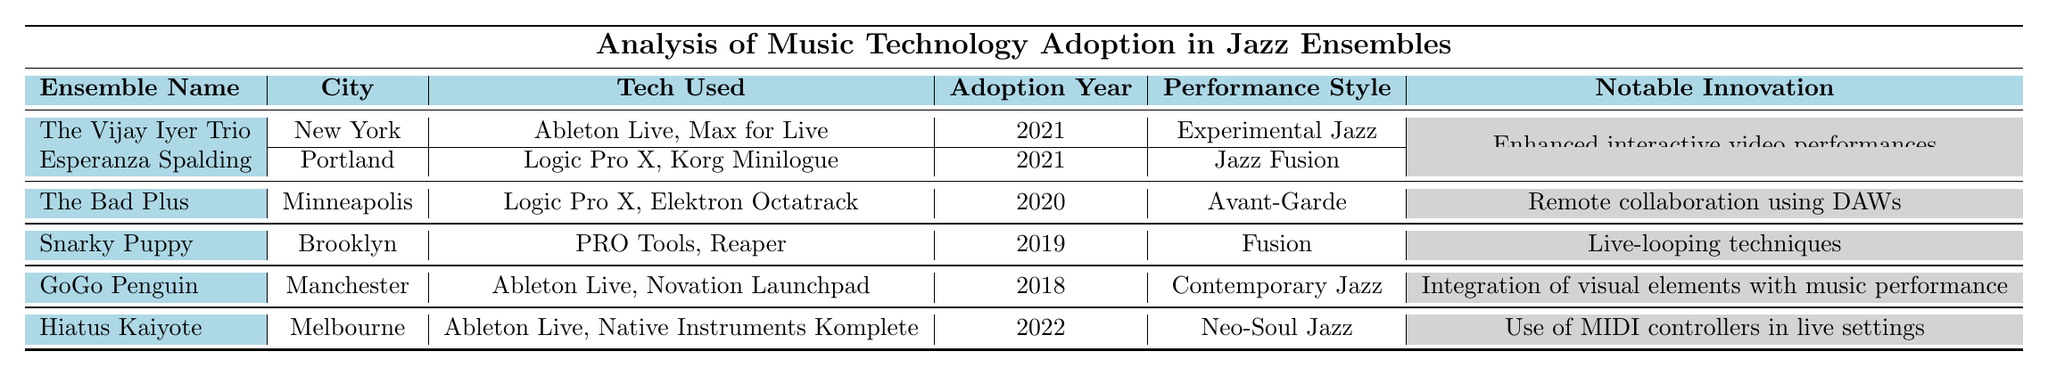What city is "The Bad Plus" based in? The table shows that "The Bad Plus" is listed under the "City" column with the corresponding entry "Minneapolis".
Answer: Minneapolis Which ensemble adopted technology in 2019? Referring to the "Adoption Year" column, the ensemble associated with the year 2019 is "Snarky Puppy".
Answer: Snarky Puppy How many ensembles adopted technology in 2021? According to the "Adoption Year" column, two ensembles - "The Vijay Iyer Trio" and "Esperanza Spalding" - are listed for 2021, which means 2 ensembles adopted technology that year.
Answer: 2 What notable innovation is associated with GoGo Penguin? The "Notable Innovation" column indicates that "GoGo Penguin" is associated with "Integration of visual elements with music performance".
Answer: Integration of visual elements with music performance Which performance style uses "Ableton Live" and was adopted in 2022? Looking at the "Tech Used" and "Adoption Year" columns, "Hiatus Kaiyote" uses "Ableton Live" and adopted technology in 2022.
Answer: Neo-Soul Jazz Is "Logic Pro X" used by any ensemble that adopted technology in 2021? Checking the table, "Logic Pro X" is used by "Esperanza Spalding", which adopted technology in 2021, confirming the statement is true.
Answer: Yes What is the difference in the adoption year of "GoGo Penguin" and "The Vijay Iyer Trio"? The table shows that "GoGo Penguin" adopted technology in 2018 and "The Vijay Iyer Trio" in 2021. The difference is 2021 - 2018 = 3 years.
Answer: 3 years Which ensemble had the most recent adoption year, and what was their notable innovation? "Hiatus Kaiyote" adopted technology in 2022, and according to the "Notable Innovation" column, their innovation was "Use of MIDI controllers in live settings".
Answer: Use of MIDI controllers in live settings How many ensembles used "Ableton Live" and what were their cities? By looking in the "Tech Used" column, "The Vijay Iyer Trio" (New York), "GoGo Penguin" (Manchester), and "Hiatus Kaiyote" (Melbourne) all use "Ableton Live". This totals to 3 ensembles.
Answer: 3 ensembles: New York, Manchester, Melbourne Are there any ensembles from the same city utilizing the same technologies? The table shows that "The Bad Plus" and "Esperanza Spalding" are both from the cities of Minneapolis and Portland, respectively, but they are using different technologies (Logic Pro X and Elektron Octatrack for "The Bad Plus", and Logic Pro X and Korg Minilogue for "Esperanza Spalding"). Therefore, the answer is no.
Answer: No 